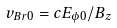Convert formula to latex. <formula><loc_0><loc_0><loc_500><loc_500>v _ { B r 0 } = c E _ { \phi 0 } / B _ { z }</formula> 